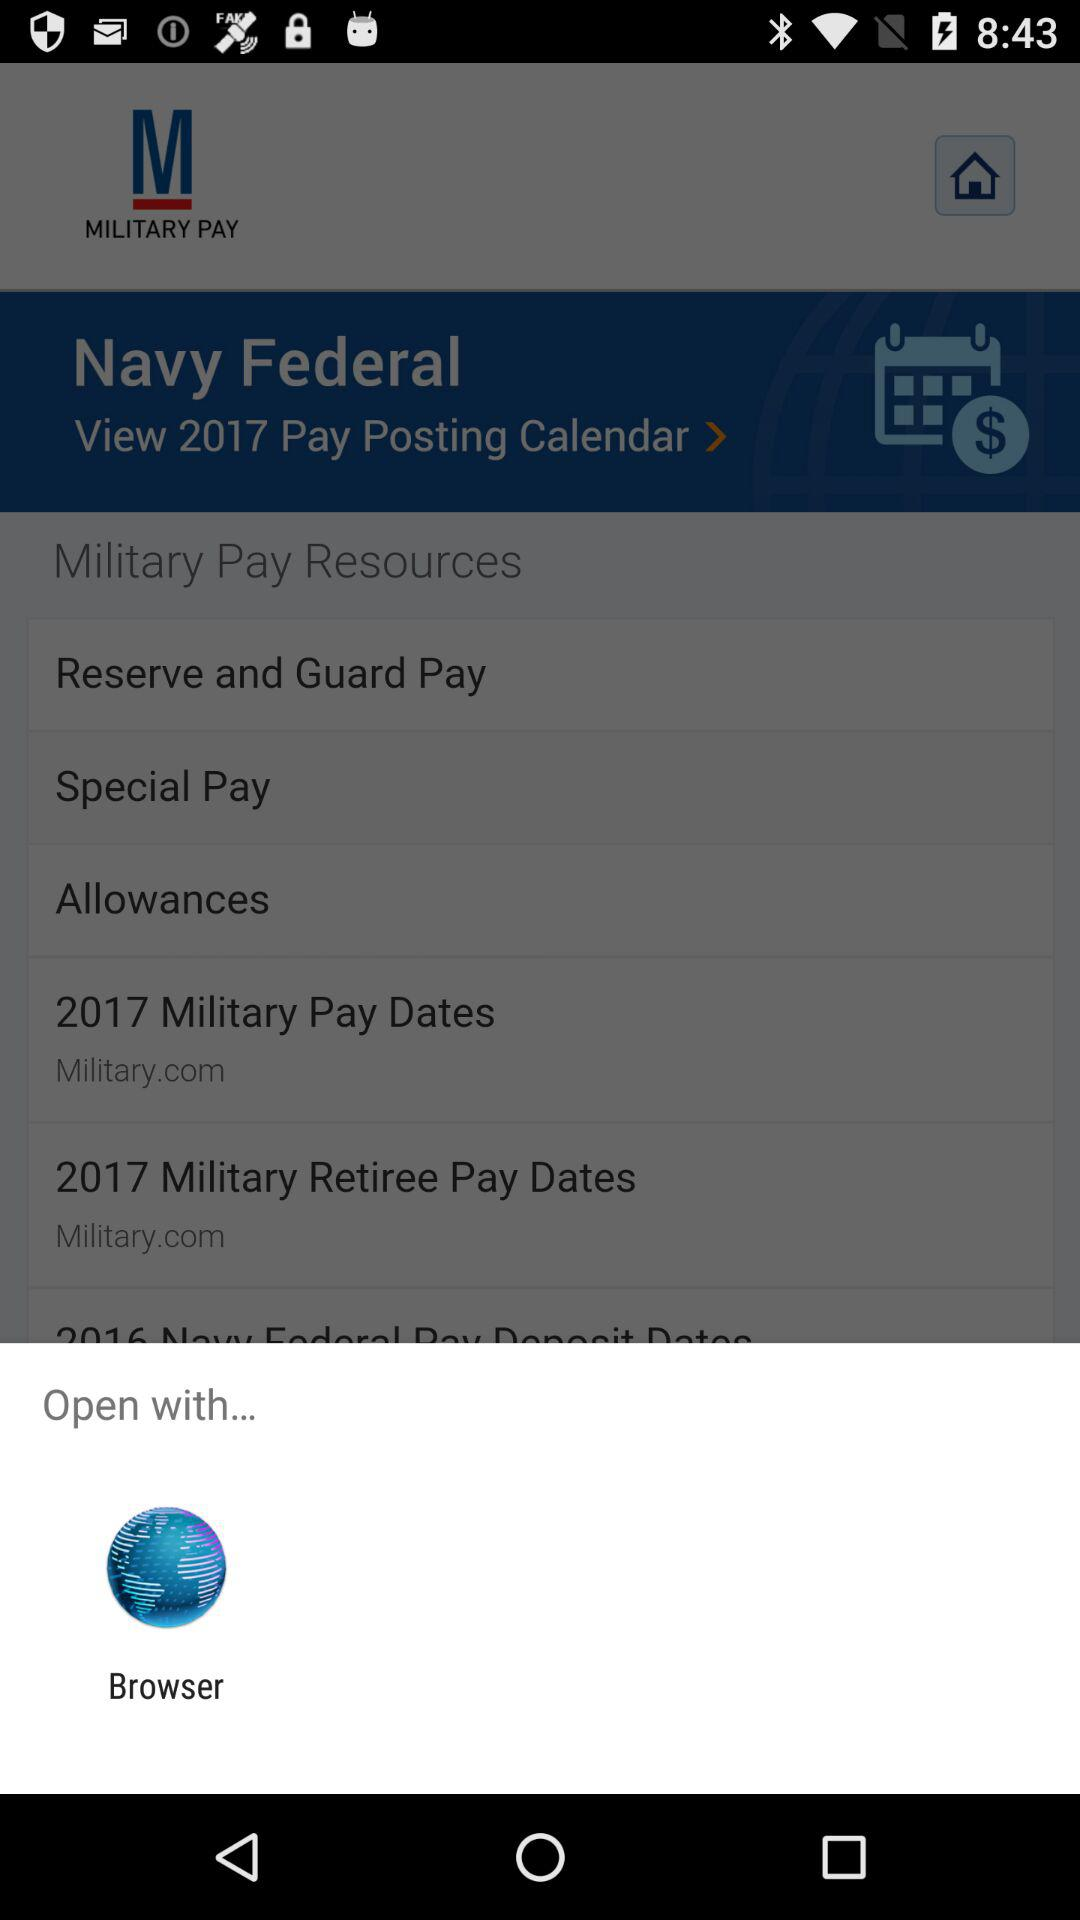What application can we use to open the document? The application that you can use to open the document is "Browser". 